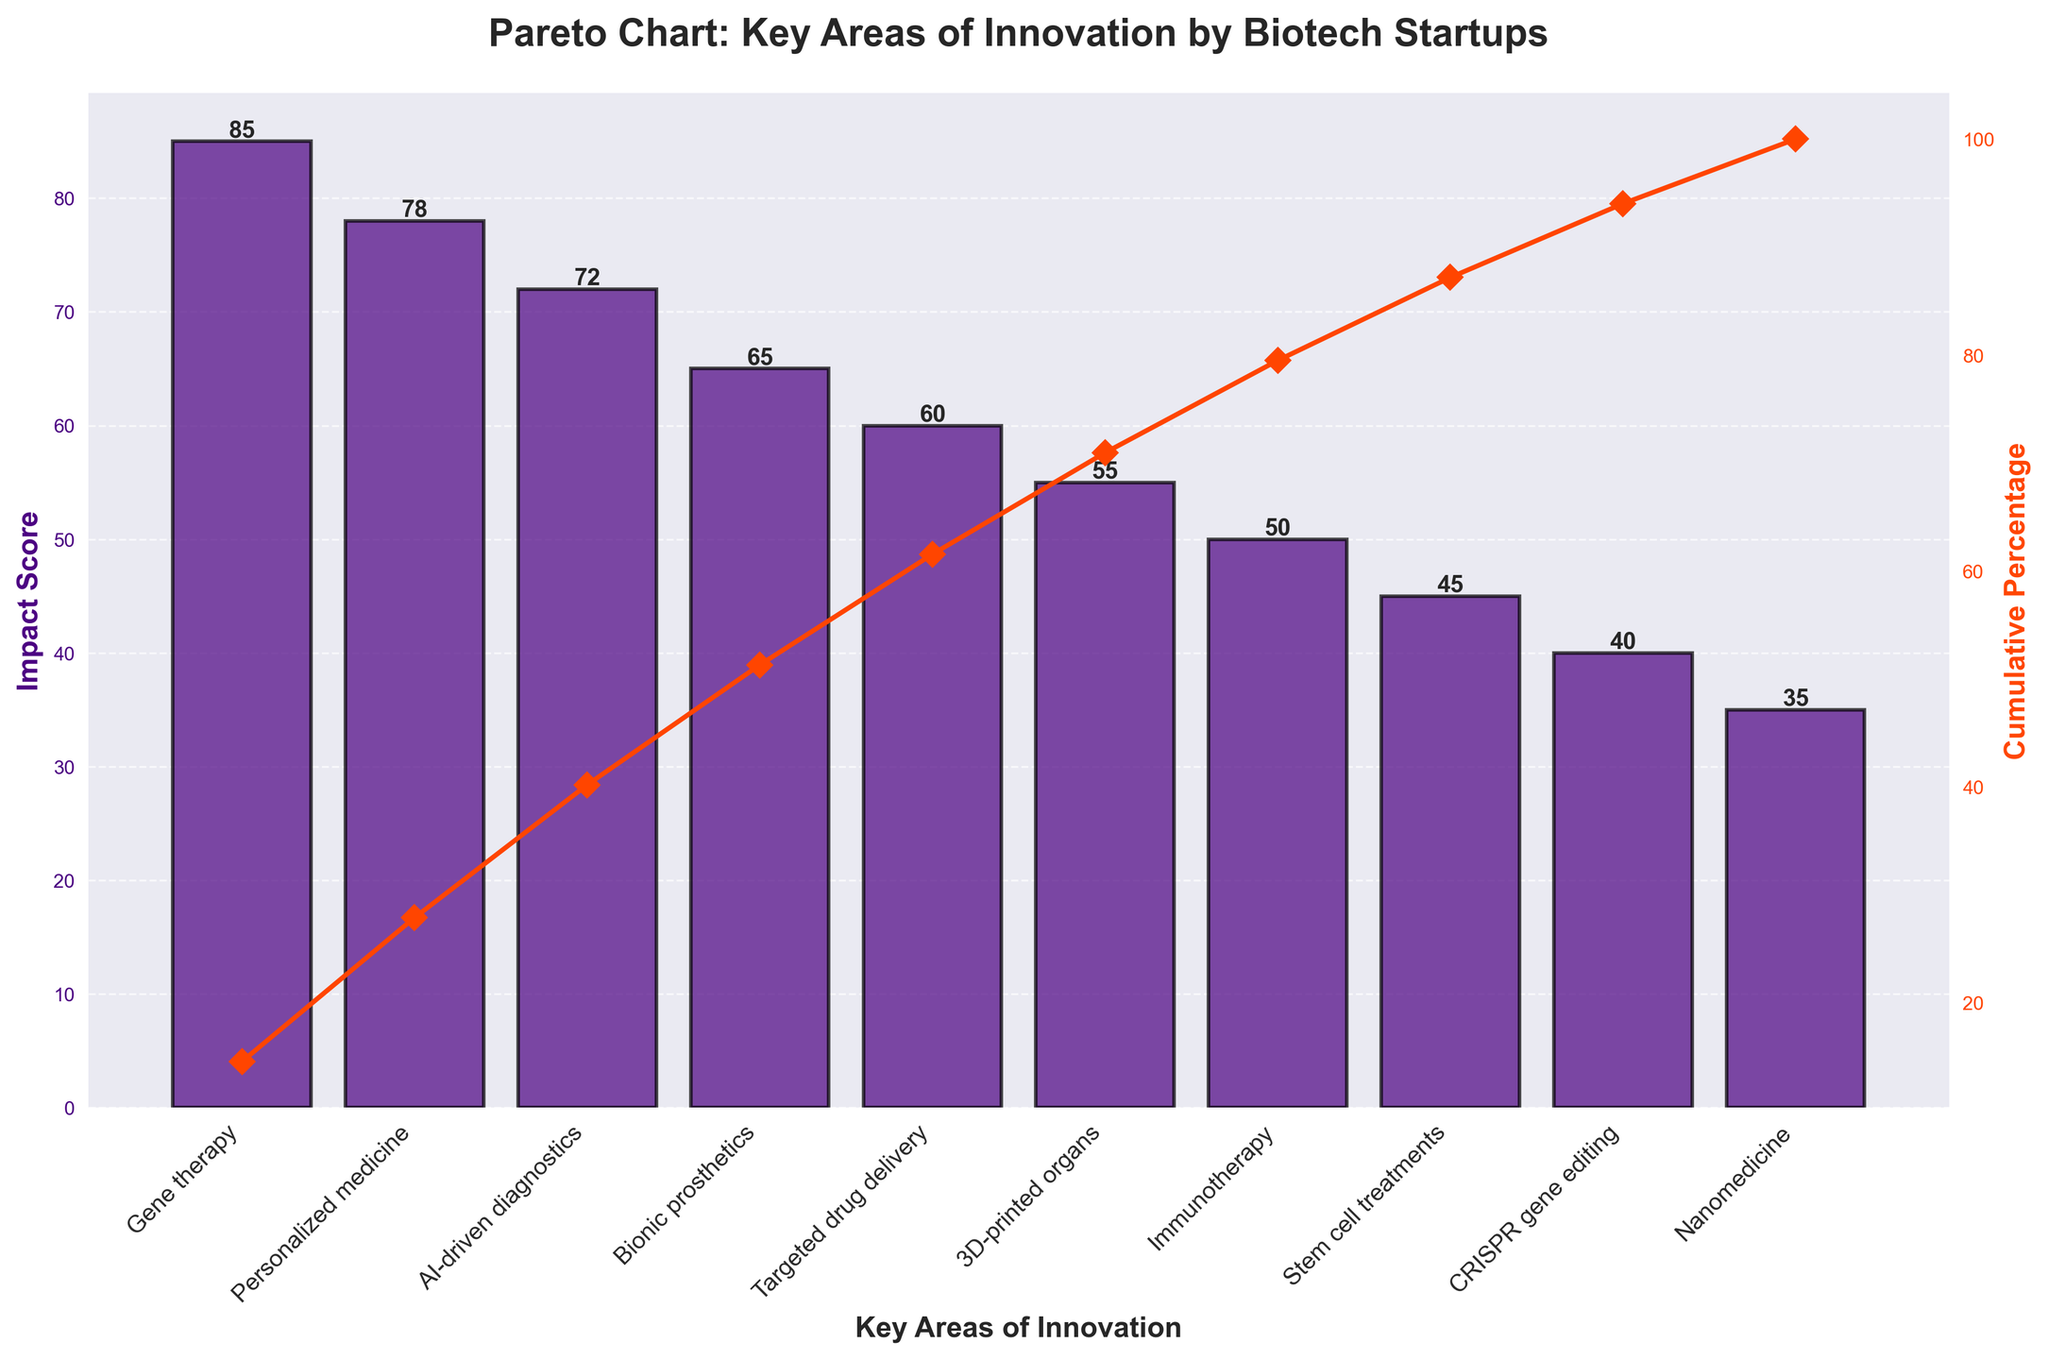How many key areas of innovation are displayed in the chart? There are 10 bars shown in the chart, each representing a distinct key area of innovation. Simply count the number of bars to get the answer.
Answer: 10 What is the title of the chart? The title is displayed at the top of the chart, indicating the subject of the figure.
Answer: Pareto Chart: Key Areas of Innovation by Biotech Startups Which innovation has the highest impact score? The chart shows bars of different heights, the tallest bar represents the innovation with the highest impact score, which is Gene therapy.
Answer: Gene therapy What is the total impact score of all innovations combined? To find the total impact score, sum up the impact scores of all the innovations listed: 85 (Gene therapy) + 78 (Personalized medicine) + 72 (AI-driven diagnostics) + 65 (Bionic prosthetics) + 60 (Targeted drug delivery) + 55 (3D-printed organs) + 50 (Immunotherapy) + 45 (Stem cell treatments) + 40 (CRISPR gene editing) + 35 (Nanomedicine) = 585.
Answer: 585 Which innovation areas cumulatively contribute to over 50% of the impact according to the cumulative percentage line? The cumulative percentage line indicates the combined impact as we move through the areas. By observing the line, we note that after AI-driven diagnostics, the cumulative percentage exceeds 50%, so Gene therapy, Personalized medicine, and AI-driven diagnostics together contribute to over 50% of the impact.
Answer: Gene therapy, Personalized medicine, AI-driven diagnostics What is the impact score for Immunotherapy? To find the impact score for Immunotherapy, locate its corresponding bar on the chart and read the value on the y-axis. The bar for Immunotherapy has a height that aligns with the impact score of 50.
Answer: 50 How do the impact scores of Bionic prosthetics and 3D-printed organs compare? Compare the height of the bars for Bionic prosthetics and 3D-printed organs. Bionic prosthetics has an impact score of 65, while 3D-printed organs have an impact score of 55. Hence, Bionic prosthetics has a higher impact score.
Answer: Bionic prosthetics has a higher impact score Which area has the lowest impact score and what is that score? The shortest bar in the chart represents the area with the lowest impact score. Nanomedicine has the lowest impact score of 35.
Answer: Nanomedicine, 35 What is the cumulative percentage after the fourth highest impact area? The cumulative percentage line's value can be read directly for the fourth highest impact area, which is Bionic prosthetics. After Bionic prosthetics, the cumulative percentage is approximately 50%.
Answer: Approximately 50% What is the difference in impact score between Gene therapy and CRISPR gene editing? Subtract the impact score of CRISPR gene editing (40) from that of Gene therapy (85). The calculation is 85 - 40 = 45.
Answer: 45 